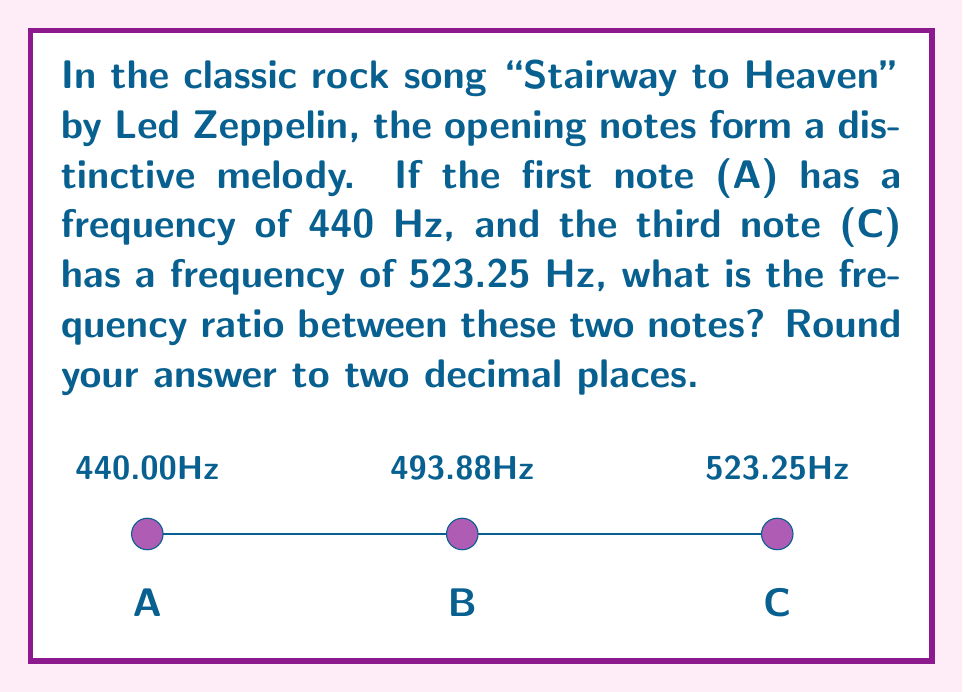Help me with this question. Let's approach this step-by-step:

1) We are given two frequencies:
   - Note A: $f_A = 440$ Hz
   - Note C: $f_C = 523.25$ Hz

2) The frequency ratio is calculated by dividing the higher frequency by the lower frequency:

   $$\text{Ratio} = \frac{f_C}{f_A}$$

3) Substituting the values:

   $$\text{Ratio} = \frac{523.25 \text{ Hz}}{440 \text{ Hz}}$$

4) Performing the division:

   $$\text{Ratio} = 1.1892045454545454...$$

5) Rounding to two decimal places:

   $$\text{Ratio} \approx 1.19$$

This ratio of 1.19 represents the musical interval known as a minor third, which is commonly used in classic rock music. In the context of "Stairway to Heaven," this interval contributes to the song's iconic and memorable opening melody.
Answer: 1.19 